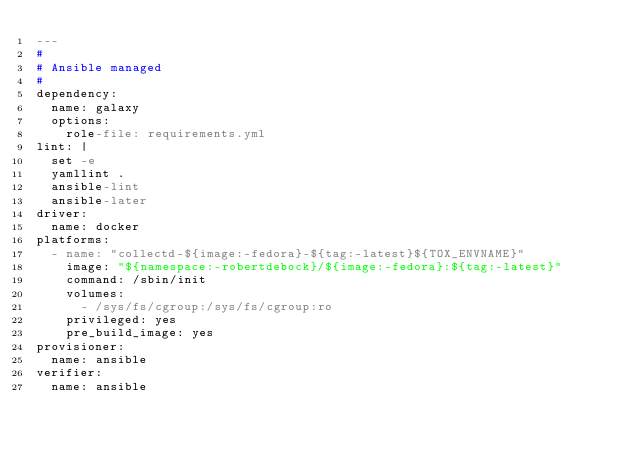Convert code to text. <code><loc_0><loc_0><loc_500><loc_500><_YAML_>---
#
# Ansible managed
#
dependency:
  name: galaxy
  options:
    role-file: requirements.yml
lint: |
  set -e
  yamllint .
  ansible-lint
  ansible-later
driver:
  name: docker
platforms:
  - name: "collectd-${image:-fedora}-${tag:-latest}${TOX_ENVNAME}"
    image: "${namespace:-robertdebock}/${image:-fedora}:${tag:-latest}"
    command: /sbin/init
    volumes:
      - /sys/fs/cgroup:/sys/fs/cgroup:ro
    privileged: yes
    pre_build_image: yes
provisioner:
  name: ansible
verifier:
  name: ansible
</code> 